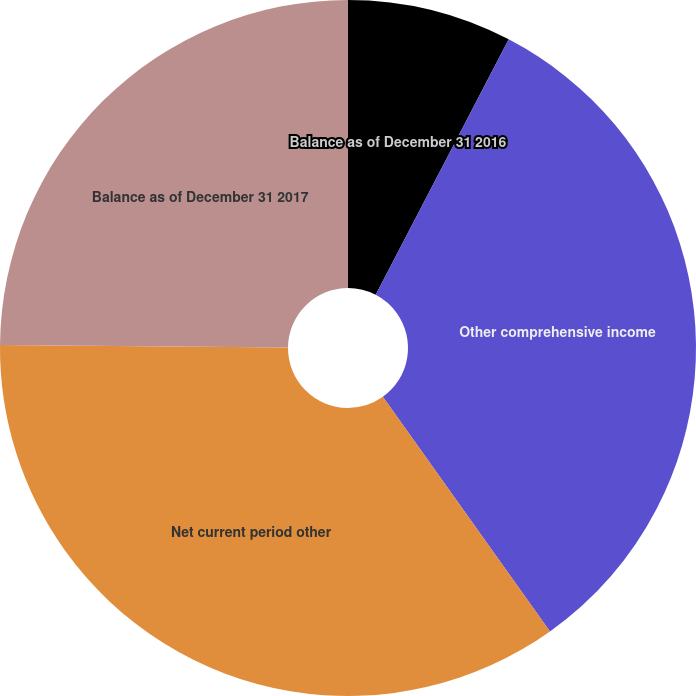<chart> <loc_0><loc_0><loc_500><loc_500><pie_chart><fcel>Balance as of December 31 2016<fcel>Other comprehensive income<fcel>Net current period other<fcel>Balance as of December 31 2017<nl><fcel>7.64%<fcel>32.5%<fcel>34.99%<fcel>24.86%<nl></chart> 